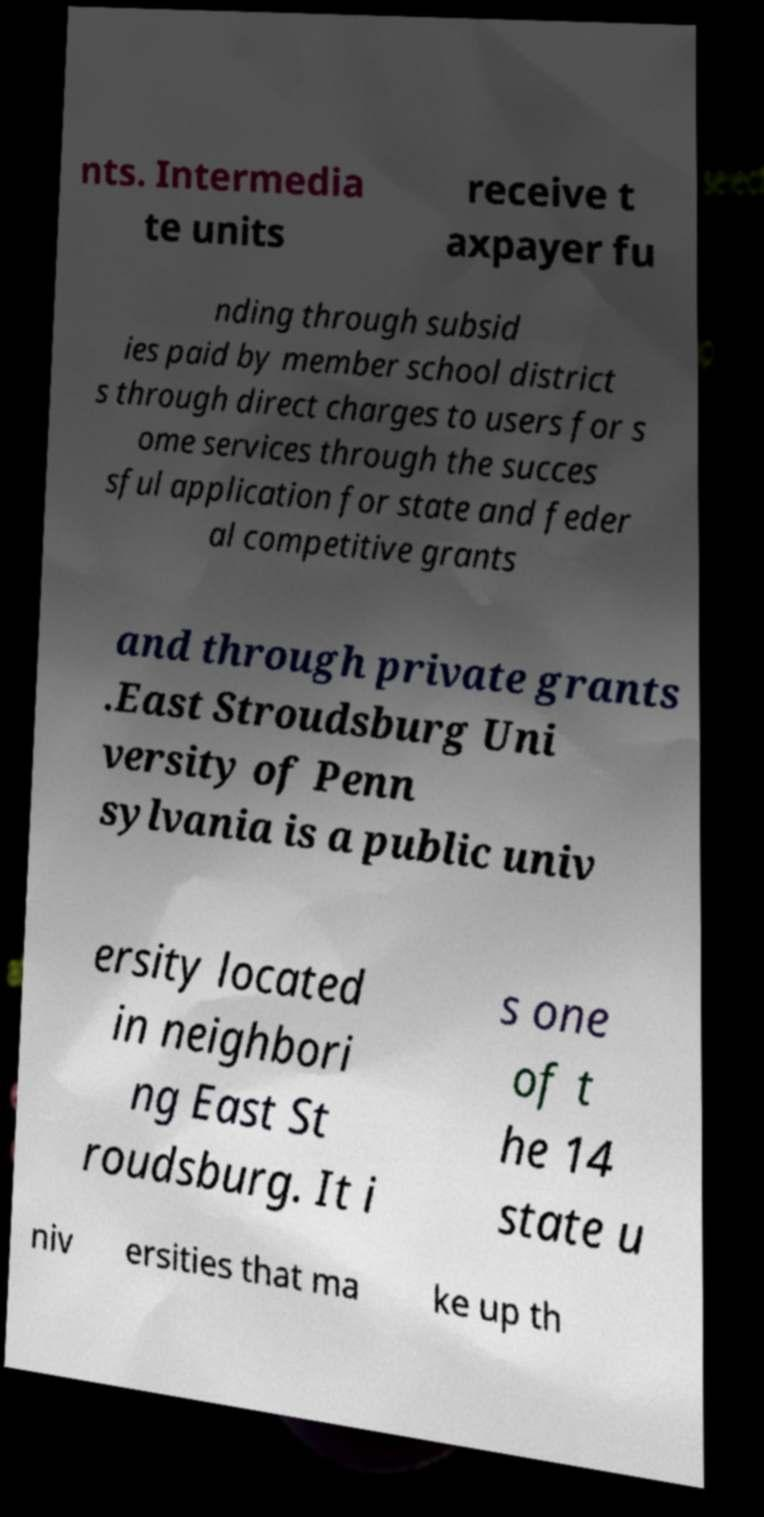There's text embedded in this image that I need extracted. Can you transcribe it verbatim? nts. Intermedia te units receive t axpayer fu nding through subsid ies paid by member school district s through direct charges to users for s ome services through the succes sful application for state and feder al competitive grants and through private grants .East Stroudsburg Uni versity of Penn sylvania is a public univ ersity located in neighbori ng East St roudsburg. It i s one of t he 14 state u niv ersities that ma ke up th 